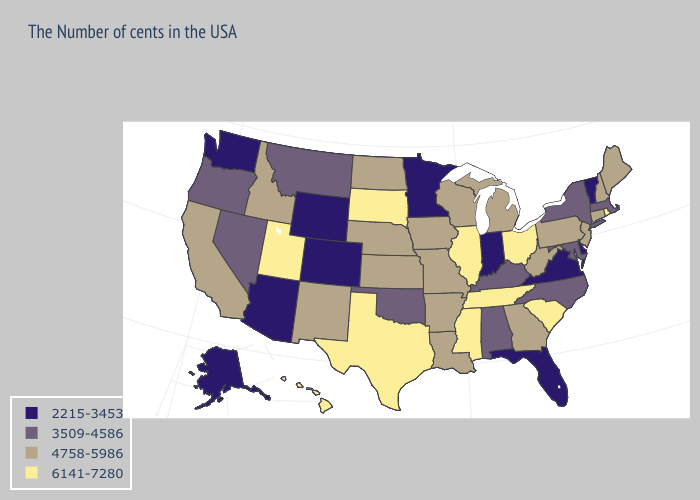Does New Hampshire have a lower value than North Carolina?
Give a very brief answer. No. Does New Hampshire have a higher value than Idaho?
Short answer required. No. What is the highest value in the South ?
Short answer required. 6141-7280. How many symbols are there in the legend?
Short answer required. 4. Among the states that border New Hampshire , which have the highest value?
Quick response, please. Maine. Name the states that have a value in the range 2215-3453?
Concise answer only. Vermont, Delaware, Virginia, Florida, Indiana, Minnesota, Wyoming, Colorado, Arizona, Washington, Alaska. What is the lowest value in the USA?
Short answer required. 2215-3453. Which states have the lowest value in the USA?
Write a very short answer. Vermont, Delaware, Virginia, Florida, Indiana, Minnesota, Wyoming, Colorado, Arizona, Washington, Alaska. What is the highest value in the USA?
Give a very brief answer. 6141-7280. Does the first symbol in the legend represent the smallest category?
Concise answer only. Yes. What is the value of Florida?
Answer briefly. 2215-3453. Name the states that have a value in the range 6141-7280?
Quick response, please. Rhode Island, South Carolina, Ohio, Tennessee, Illinois, Mississippi, Texas, South Dakota, Utah, Hawaii. Among the states that border Delaware , which have the lowest value?
Be succinct. Maryland. What is the value of Virginia?
Answer briefly. 2215-3453. Does the first symbol in the legend represent the smallest category?
Concise answer only. Yes. 